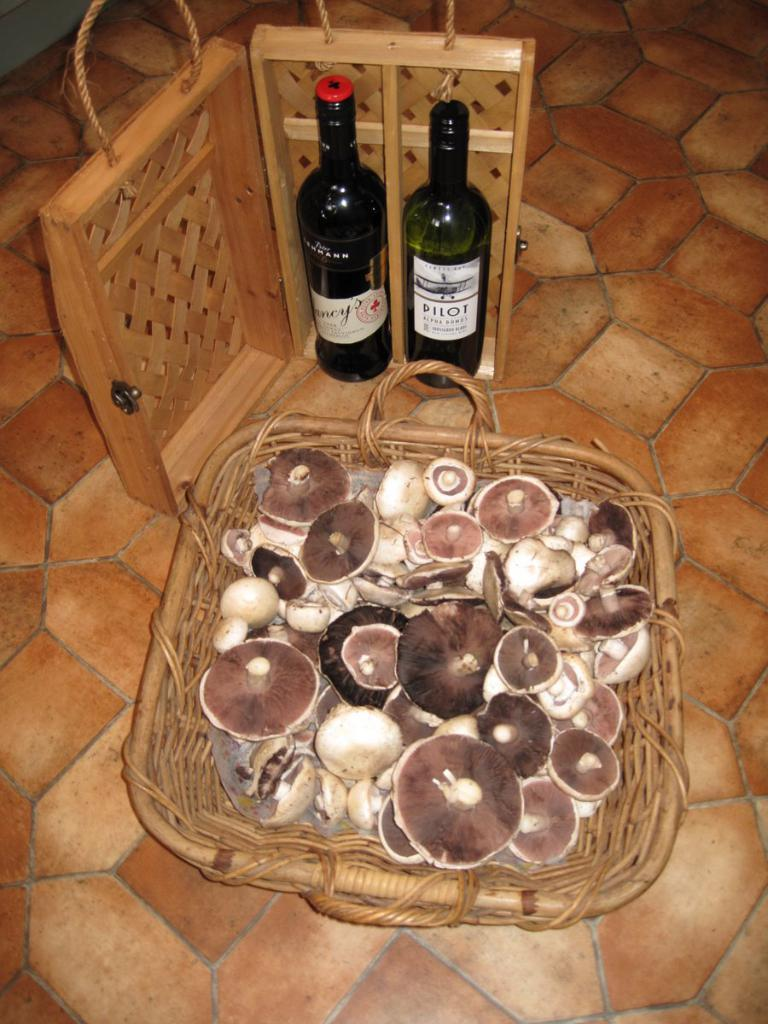<image>
Relay a brief, clear account of the picture shown. Bottle of Pilot Wine and Bottle of Nancy's wine. 